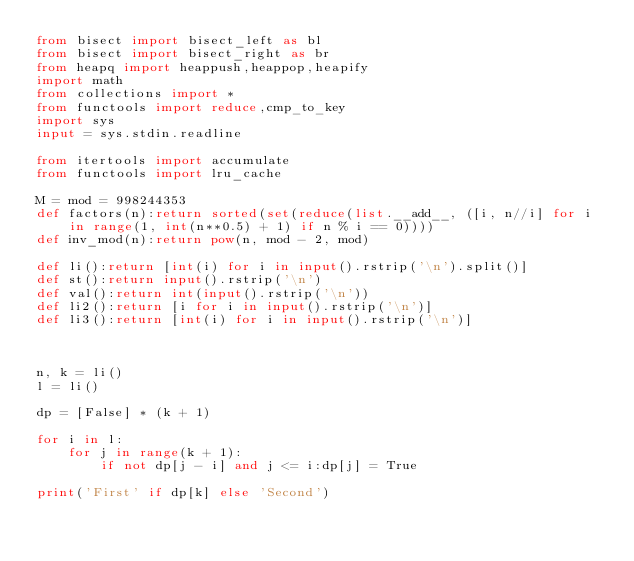<code> <loc_0><loc_0><loc_500><loc_500><_Python_>from bisect import bisect_left as bl
from bisect import bisect_right as br
from heapq import heappush,heappop,heapify
import math
from collections import *
from functools import reduce,cmp_to_key
import sys
input = sys.stdin.readline

from itertools import accumulate
from functools import lru_cache

M = mod = 998244353
def factors(n):return sorted(set(reduce(list.__add__, ([i, n//i] for i in range(1, int(n**0.5) + 1) if n % i == 0))))
def inv_mod(n):return pow(n, mod - 2, mod)
 
def li():return [int(i) for i in input().rstrip('\n').split()]
def st():return input().rstrip('\n')
def val():return int(input().rstrip('\n'))
def li2():return [i for i in input().rstrip('\n')]
def li3():return [int(i) for i in input().rstrip('\n')]



n, k = li()
l = li()

dp = [False] * (k + 1)

for i in l:
    for j in range(k + 1):
        if not dp[j - i] and j <= i:dp[j] = True

print('First' if dp[k] else 'Second')</code> 